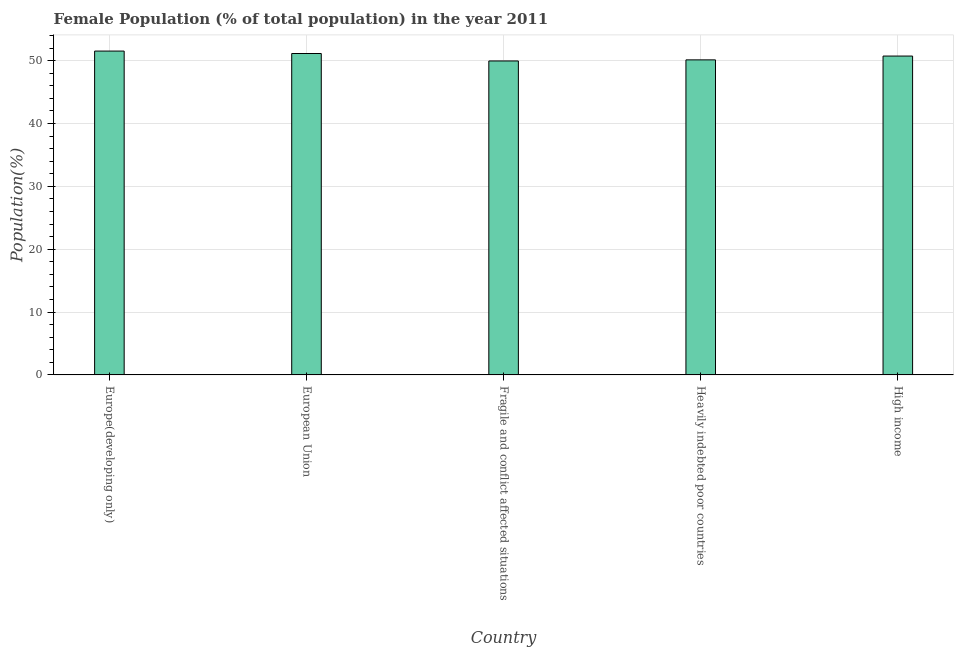Does the graph contain any zero values?
Make the answer very short. No. Does the graph contain grids?
Provide a short and direct response. Yes. What is the title of the graph?
Provide a short and direct response. Female Population (% of total population) in the year 2011. What is the label or title of the Y-axis?
Keep it short and to the point. Population(%). What is the female population in High income?
Offer a terse response. 50.74. Across all countries, what is the maximum female population?
Offer a terse response. 51.54. Across all countries, what is the minimum female population?
Ensure brevity in your answer.  49.96. In which country was the female population maximum?
Provide a succinct answer. Europe(developing only). In which country was the female population minimum?
Keep it short and to the point. Fragile and conflict affected situations. What is the sum of the female population?
Your answer should be compact. 253.53. What is the difference between the female population in Europe(developing only) and European Union?
Ensure brevity in your answer.  0.39. What is the average female population per country?
Offer a terse response. 50.7. What is the median female population?
Make the answer very short. 50.74. In how many countries, is the female population greater than 36 %?
Give a very brief answer. 5. Is the female population in Europe(developing only) less than that in Heavily indebted poor countries?
Offer a terse response. No. What is the difference between the highest and the second highest female population?
Ensure brevity in your answer.  0.39. Is the sum of the female population in European Union and Heavily indebted poor countries greater than the maximum female population across all countries?
Provide a succinct answer. Yes. What is the difference between the highest and the lowest female population?
Offer a terse response. 1.57. In how many countries, is the female population greater than the average female population taken over all countries?
Offer a very short reply. 3. How many bars are there?
Ensure brevity in your answer.  5. How many countries are there in the graph?
Your answer should be compact. 5. Are the values on the major ticks of Y-axis written in scientific E-notation?
Offer a very short reply. No. What is the Population(%) in Europe(developing only)?
Ensure brevity in your answer.  51.54. What is the Population(%) in European Union?
Your response must be concise. 51.15. What is the Population(%) in Fragile and conflict affected situations?
Offer a terse response. 49.96. What is the Population(%) in Heavily indebted poor countries?
Your answer should be compact. 50.14. What is the Population(%) of High income?
Offer a very short reply. 50.74. What is the difference between the Population(%) in Europe(developing only) and European Union?
Provide a short and direct response. 0.39. What is the difference between the Population(%) in Europe(developing only) and Fragile and conflict affected situations?
Ensure brevity in your answer.  1.57. What is the difference between the Population(%) in Europe(developing only) and Heavily indebted poor countries?
Keep it short and to the point. 1.4. What is the difference between the Population(%) in Europe(developing only) and High income?
Your response must be concise. 0.79. What is the difference between the Population(%) in European Union and Fragile and conflict affected situations?
Your answer should be compact. 1.18. What is the difference between the Population(%) in European Union and Heavily indebted poor countries?
Provide a succinct answer. 1.01. What is the difference between the Population(%) in European Union and High income?
Give a very brief answer. 0.4. What is the difference between the Population(%) in Fragile and conflict affected situations and Heavily indebted poor countries?
Make the answer very short. -0.17. What is the difference between the Population(%) in Fragile and conflict affected situations and High income?
Provide a succinct answer. -0.78. What is the difference between the Population(%) in Heavily indebted poor countries and High income?
Provide a succinct answer. -0.61. What is the ratio of the Population(%) in Europe(developing only) to that in European Union?
Offer a terse response. 1.01. What is the ratio of the Population(%) in Europe(developing only) to that in Fragile and conflict affected situations?
Your answer should be compact. 1.03. What is the ratio of the Population(%) in Europe(developing only) to that in Heavily indebted poor countries?
Offer a very short reply. 1.03. What is the ratio of the Population(%) in Europe(developing only) to that in High income?
Give a very brief answer. 1.02. What is the ratio of the Population(%) in European Union to that in Fragile and conflict affected situations?
Provide a short and direct response. 1.02. What is the ratio of the Population(%) in Fragile and conflict affected situations to that in Heavily indebted poor countries?
Keep it short and to the point. 1. What is the ratio of the Population(%) in Heavily indebted poor countries to that in High income?
Make the answer very short. 0.99. 